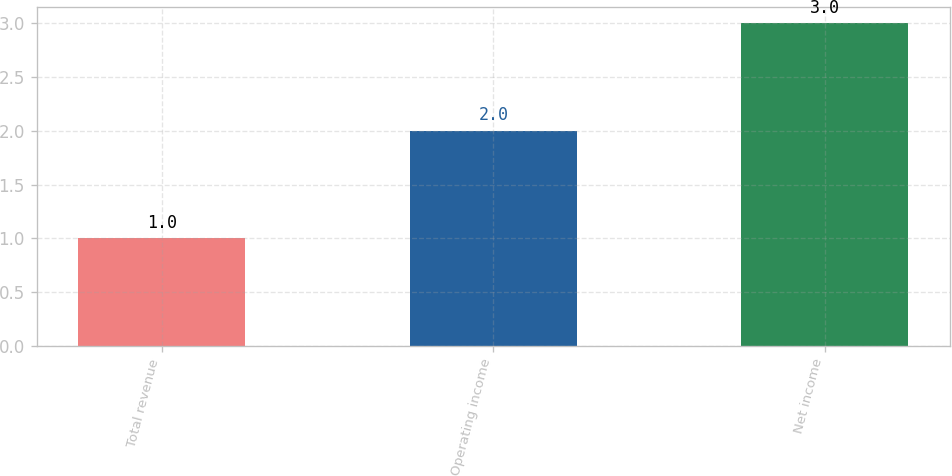Convert chart. <chart><loc_0><loc_0><loc_500><loc_500><bar_chart><fcel>Total revenue<fcel>Operating income<fcel>Net income<nl><fcel>1<fcel>2<fcel>3<nl></chart> 